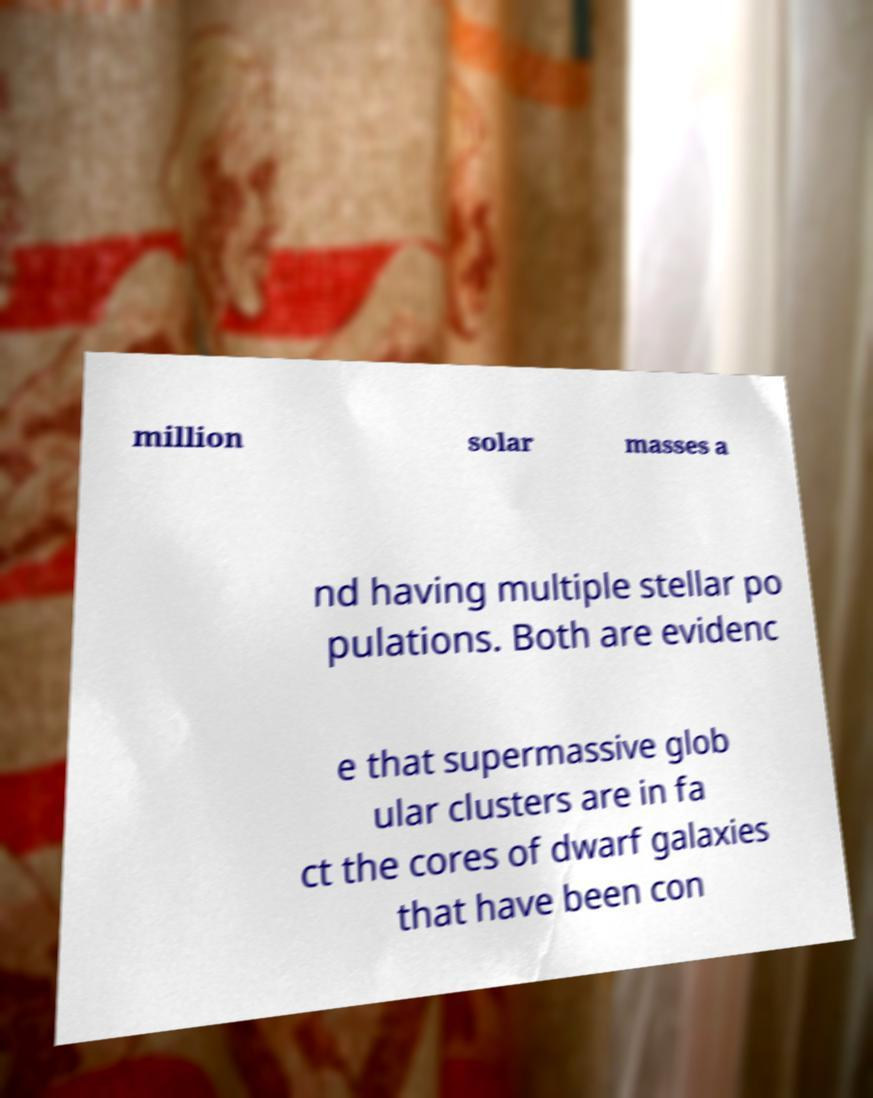What messages or text are displayed in this image? I need them in a readable, typed format. million solar masses a nd having multiple stellar po pulations. Both are evidenc e that supermassive glob ular clusters are in fa ct the cores of dwarf galaxies that have been con 